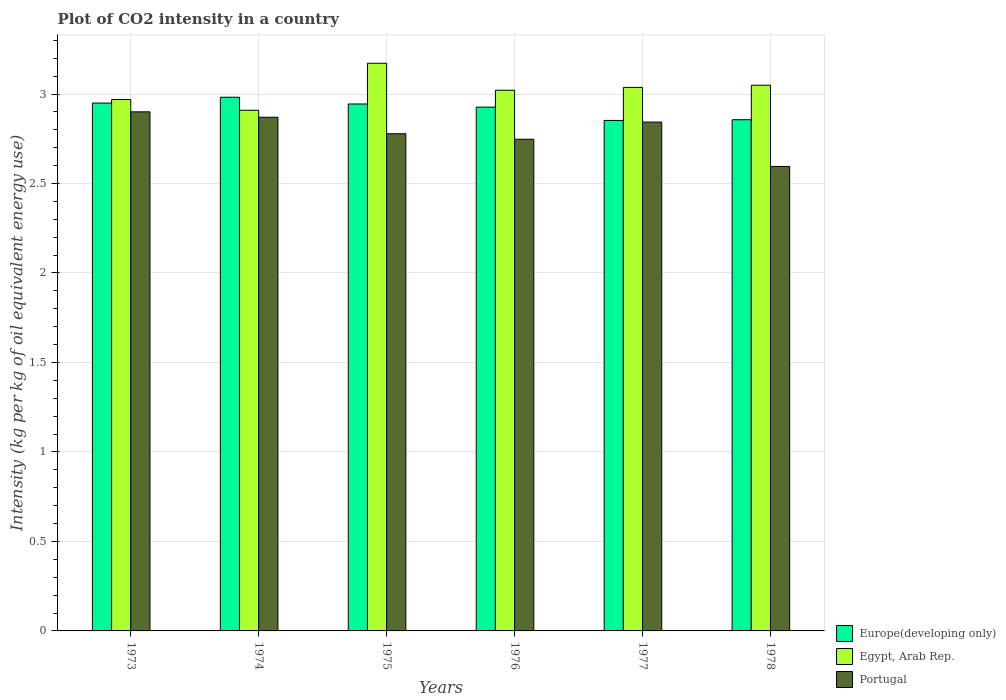How many different coloured bars are there?
Offer a terse response. 3. How many groups of bars are there?
Make the answer very short. 6. Are the number of bars per tick equal to the number of legend labels?
Your answer should be compact. Yes. Are the number of bars on each tick of the X-axis equal?
Offer a very short reply. Yes. How many bars are there on the 5th tick from the left?
Offer a very short reply. 3. What is the label of the 5th group of bars from the left?
Your response must be concise. 1977. What is the CO2 intensity in in Portugal in 1976?
Provide a succinct answer. 2.75. Across all years, what is the maximum CO2 intensity in in Europe(developing only)?
Your answer should be compact. 2.98. Across all years, what is the minimum CO2 intensity in in Egypt, Arab Rep.?
Provide a succinct answer. 2.91. In which year was the CO2 intensity in in Egypt, Arab Rep. maximum?
Your answer should be compact. 1975. What is the total CO2 intensity in in Egypt, Arab Rep. in the graph?
Your response must be concise. 18.16. What is the difference between the CO2 intensity in in Egypt, Arab Rep. in 1975 and that in 1976?
Make the answer very short. 0.15. What is the difference between the CO2 intensity in in Egypt, Arab Rep. in 1975 and the CO2 intensity in in Europe(developing only) in 1976?
Ensure brevity in your answer.  0.25. What is the average CO2 intensity in in Egypt, Arab Rep. per year?
Your answer should be very brief. 3.03. In the year 1975, what is the difference between the CO2 intensity in in Portugal and CO2 intensity in in Europe(developing only)?
Give a very brief answer. -0.17. In how many years, is the CO2 intensity in in Egypt, Arab Rep. greater than 1.1 kg?
Offer a terse response. 6. What is the ratio of the CO2 intensity in in Portugal in 1975 to that in 1977?
Your answer should be compact. 0.98. Is the CO2 intensity in in Europe(developing only) in 1973 less than that in 1976?
Ensure brevity in your answer.  No. Is the difference between the CO2 intensity in in Portugal in 1974 and 1977 greater than the difference between the CO2 intensity in in Europe(developing only) in 1974 and 1977?
Your answer should be very brief. No. What is the difference between the highest and the second highest CO2 intensity in in Egypt, Arab Rep.?
Your response must be concise. 0.12. What is the difference between the highest and the lowest CO2 intensity in in Egypt, Arab Rep.?
Keep it short and to the point. 0.26. What does the 2nd bar from the left in 1974 represents?
Provide a short and direct response. Egypt, Arab Rep. What does the 1st bar from the right in 1974 represents?
Your answer should be very brief. Portugal. How many bars are there?
Your answer should be compact. 18. Does the graph contain any zero values?
Provide a succinct answer. No. Does the graph contain grids?
Offer a terse response. Yes. What is the title of the graph?
Make the answer very short. Plot of CO2 intensity in a country. What is the label or title of the X-axis?
Make the answer very short. Years. What is the label or title of the Y-axis?
Provide a short and direct response. Intensity (kg per kg of oil equivalent energy use). What is the Intensity (kg per kg of oil equivalent energy use) of Europe(developing only) in 1973?
Your answer should be very brief. 2.95. What is the Intensity (kg per kg of oil equivalent energy use) in Egypt, Arab Rep. in 1973?
Provide a short and direct response. 2.97. What is the Intensity (kg per kg of oil equivalent energy use) in Portugal in 1973?
Make the answer very short. 2.9. What is the Intensity (kg per kg of oil equivalent energy use) in Europe(developing only) in 1974?
Give a very brief answer. 2.98. What is the Intensity (kg per kg of oil equivalent energy use) in Egypt, Arab Rep. in 1974?
Your response must be concise. 2.91. What is the Intensity (kg per kg of oil equivalent energy use) in Portugal in 1974?
Your response must be concise. 2.87. What is the Intensity (kg per kg of oil equivalent energy use) of Europe(developing only) in 1975?
Offer a terse response. 2.94. What is the Intensity (kg per kg of oil equivalent energy use) in Egypt, Arab Rep. in 1975?
Your response must be concise. 3.17. What is the Intensity (kg per kg of oil equivalent energy use) of Portugal in 1975?
Your answer should be compact. 2.78. What is the Intensity (kg per kg of oil equivalent energy use) of Europe(developing only) in 1976?
Keep it short and to the point. 2.93. What is the Intensity (kg per kg of oil equivalent energy use) of Egypt, Arab Rep. in 1976?
Make the answer very short. 3.02. What is the Intensity (kg per kg of oil equivalent energy use) of Portugal in 1976?
Provide a short and direct response. 2.75. What is the Intensity (kg per kg of oil equivalent energy use) in Europe(developing only) in 1977?
Offer a terse response. 2.85. What is the Intensity (kg per kg of oil equivalent energy use) in Egypt, Arab Rep. in 1977?
Provide a short and direct response. 3.04. What is the Intensity (kg per kg of oil equivalent energy use) of Portugal in 1977?
Ensure brevity in your answer.  2.84. What is the Intensity (kg per kg of oil equivalent energy use) of Europe(developing only) in 1978?
Offer a terse response. 2.86. What is the Intensity (kg per kg of oil equivalent energy use) of Egypt, Arab Rep. in 1978?
Offer a terse response. 3.05. What is the Intensity (kg per kg of oil equivalent energy use) of Portugal in 1978?
Provide a succinct answer. 2.6. Across all years, what is the maximum Intensity (kg per kg of oil equivalent energy use) of Europe(developing only)?
Ensure brevity in your answer.  2.98. Across all years, what is the maximum Intensity (kg per kg of oil equivalent energy use) in Egypt, Arab Rep.?
Your response must be concise. 3.17. Across all years, what is the maximum Intensity (kg per kg of oil equivalent energy use) in Portugal?
Give a very brief answer. 2.9. Across all years, what is the minimum Intensity (kg per kg of oil equivalent energy use) of Europe(developing only)?
Make the answer very short. 2.85. Across all years, what is the minimum Intensity (kg per kg of oil equivalent energy use) in Egypt, Arab Rep.?
Keep it short and to the point. 2.91. Across all years, what is the minimum Intensity (kg per kg of oil equivalent energy use) of Portugal?
Keep it short and to the point. 2.6. What is the total Intensity (kg per kg of oil equivalent energy use) in Europe(developing only) in the graph?
Keep it short and to the point. 17.51. What is the total Intensity (kg per kg of oil equivalent energy use) of Egypt, Arab Rep. in the graph?
Your answer should be very brief. 18.16. What is the total Intensity (kg per kg of oil equivalent energy use) of Portugal in the graph?
Give a very brief answer. 16.74. What is the difference between the Intensity (kg per kg of oil equivalent energy use) in Europe(developing only) in 1973 and that in 1974?
Make the answer very short. -0.03. What is the difference between the Intensity (kg per kg of oil equivalent energy use) in Portugal in 1973 and that in 1974?
Provide a succinct answer. 0.03. What is the difference between the Intensity (kg per kg of oil equivalent energy use) in Europe(developing only) in 1973 and that in 1975?
Ensure brevity in your answer.  0.01. What is the difference between the Intensity (kg per kg of oil equivalent energy use) in Egypt, Arab Rep. in 1973 and that in 1975?
Provide a succinct answer. -0.2. What is the difference between the Intensity (kg per kg of oil equivalent energy use) in Portugal in 1973 and that in 1975?
Make the answer very short. 0.12. What is the difference between the Intensity (kg per kg of oil equivalent energy use) of Europe(developing only) in 1973 and that in 1976?
Ensure brevity in your answer.  0.02. What is the difference between the Intensity (kg per kg of oil equivalent energy use) of Egypt, Arab Rep. in 1973 and that in 1976?
Your answer should be compact. -0.05. What is the difference between the Intensity (kg per kg of oil equivalent energy use) of Portugal in 1973 and that in 1976?
Offer a terse response. 0.15. What is the difference between the Intensity (kg per kg of oil equivalent energy use) of Europe(developing only) in 1973 and that in 1977?
Provide a succinct answer. 0.1. What is the difference between the Intensity (kg per kg of oil equivalent energy use) in Egypt, Arab Rep. in 1973 and that in 1977?
Keep it short and to the point. -0.07. What is the difference between the Intensity (kg per kg of oil equivalent energy use) in Portugal in 1973 and that in 1977?
Your answer should be compact. 0.06. What is the difference between the Intensity (kg per kg of oil equivalent energy use) of Europe(developing only) in 1973 and that in 1978?
Keep it short and to the point. 0.09. What is the difference between the Intensity (kg per kg of oil equivalent energy use) of Egypt, Arab Rep. in 1973 and that in 1978?
Your answer should be very brief. -0.08. What is the difference between the Intensity (kg per kg of oil equivalent energy use) in Portugal in 1973 and that in 1978?
Provide a short and direct response. 0.31. What is the difference between the Intensity (kg per kg of oil equivalent energy use) of Europe(developing only) in 1974 and that in 1975?
Offer a terse response. 0.04. What is the difference between the Intensity (kg per kg of oil equivalent energy use) of Egypt, Arab Rep. in 1974 and that in 1975?
Make the answer very short. -0.26. What is the difference between the Intensity (kg per kg of oil equivalent energy use) of Portugal in 1974 and that in 1975?
Provide a succinct answer. 0.09. What is the difference between the Intensity (kg per kg of oil equivalent energy use) in Europe(developing only) in 1974 and that in 1976?
Offer a very short reply. 0.06. What is the difference between the Intensity (kg per kg of oil equivalent energy use) in Egypt, Arab Rep. in 1974 and that in 1976?
Your answer should be very brief. -0.11. What is the difference between the Intensity (kg per kg of oil equivalent energy use) of Portugal in 1974 and that in 1976?
Provide a succinct answer. 0.12. What is the difference between the Intensity (kg per kg of oil equivalent energy use) of Europe(developing only) in 1974 and that in 1977?
Offer a very short reply. 0.13. What is the difference between the Intensity (kg per kg of oil equivalent energy use) in Egypt, Arab Rep. in 1974 and that in 1977?
Offer a terse response. -0.13. What is the difference between the Intensity (kg per kg of oil equivalent energy use) of Portugal in 1974 and that in 1977?
Keep it short and to the point. 0.03. What is the difference between the Intensity (kg per kg of oil equivalent energy use) in Europe(developing only) in 1974 and that in 1978?
Give a very brief answer. 0.13. What is the difference between the Intensity (kg per kg of oil equivalent energy use) of Egypt, Arab Rep. in 1974 and that in 1978?
Ensure brevity in your answer.  -0.14. What is the difference between the Intensity (kg per kg of oil equivalent energy use) of Portugal in 1974 and that in 1978?
Offer a very short reply. 0.28. What is the difference between the Intensity (kg per kg of oil equivalent energy use) in Europe(developing only) in 1975 and that in 1976?
Ensure brevity in your answer.  0.02. What is the difference between the Intensity (kg per kg of oil equivalent energy use) in Egypt, Arab Rep. in 1975 and that in 1976?
Offer a terse response. 0.15. What is the difference between the Intensity (kg per kg of oil equivalent energy use) of Portugal in 1975 and that in 1976?
Keep it short and to the point. 0.03. What is the difference between the Intensity (kg per kg of oil equivalent energy use) in Europe(developing only) in 1975 and that in 1977?
Your response must be concise. 0.09. What is the difference between the Intensity (kg per kg of oil equivalent energy use) of Egypt, Arab Rep. in 1975 and that in 1977?
Your response must be concise. 0.13. What is the difference between the Intensity (kg per kg of oil equivalent energy use) in Portugal in 1975 and that in 1977?
Ensure brevity in your answer.  -0.07. What is the difference between the Intensity (kg per kg of oil equivalent energy use) in Europe(developing only) in 1975 and that in 1978?
Your response must be concise. 0.09. What is the difference between the Intensity (kg per kg of oil equivalent energy use) in Egypt, Arab Rep. in 1975 and that in 1978?
Keep it short and to the point. 0.12. What is the difference between the Intensity (kg per kg of oil equivalent energy use) of Portugal in 1975 and that in 1978?
Give a very brief answer. 0.18. What is the difference between the Intensity (kg per kg of oil equivalent energy use) of Europe(developing only) in 1976 and that in 1977?
Provide a short and direct response. 0.07. What is the difference between the Intensity (kg per kg of oil equivalent energy use) in Egypt, Arab Rep. in 1976 and that in 1977?
Your answer should be compact. -0.02. What is the difference between the Intensity (kg per kg of oil equivalent energy use) of Portugal in 1976 and that in 1977?
Make the answer very short. -0.1. What is the difference between the Intensity (kg per kg of oil equivalent energy use) of Europe(developing only) in 1976 and that in 1978?
Keep it short and to the point. 0.07. What is the difference between the Intensity (kg per kg of oil equivalent energy use) in Egypt, Arab Rep. in 1976 and that in 1978?
Your response must be concise. -0.03. What is the difference between the Intensity (kg per kg of oil equivalent energy use) in Portugal in 1976 and that in 1978?
Make the answer very short. 0.15. What is the difference between the Intensity (kg per kg of oil equivalent energy use) in Europe(developing only) in 1977 and that in 1978?
Provide a short and direct response. -0. What is the difference between the Intensity (kg per kg of oil equivalent energy use) in Egypt, Arab Rep. in 1977 and that in 1978?
Ensure brevity in your answer.  -0.01. What is the difference between the Intensity (kg per kg of oil equivalent energy use) of Portugal in 1977 and that in 1978?
Ensure brevity in your answer.  0.25. What is the difference between the Intensity (kg per kg of oil equivalent energy use) of Europe(developing only) in 1973 and the Intensity (kg per kg of oil equivalent energy use) of Egypt, Arab Rep. in 1974?
Your answer should be compact. 0.04. What is the difference between the Intensity (kg per kg of oil equivalent energy use) in Europe(developing only) in 1973 and the Intensity (kg per kg of oil equivalent energy use) in Portugal in 1974?
Your response must be concise. 0.08. What is the difference between the Intensity (kg per kg of oil equivalent energy use) of Egypt, Arab Rep. in 1973 and the Intensity (kg per kg of oil equivalent energy use) of Portugal in 1974?
Your answer should be compact. 0.1. What is the difference between the Intensity (kg per kg of oil equivalent energy use) of Europe(developing only) in 1973 and the Intensity (kg per kg of oil equivalent energy use) of Egypt, Arab Rep. in 1975?
Your answer should be compact. -0.22. What is the difference between the Intensity (kg per kg of oil equivalent energy use) in Europe(developing only) in 1973 and the Intensity (kg per kg of oil equivalent energy use) in Portugal in 1975?
Provide a short and direct response. 0.17. What is the difference between the Intensity (kg per kg of oil equivalent energy use) of Egypt, Arab Rep. in 1973 and the Intensity (kg per kg of oil equivalent energy use) of Portugal in 1975?
Your response must be concise. 0.19. What is the difference between the Intensity (kg per kg of oil equivalent energy use) in Europe(developing only) in 1973 and the Intensity (kg per kg of oil equivalent energy use) in Egypt, Arab Rep. in 1976?
Give a very brief answer. -0.07. What is the difference between the Intensity (kg per kg of oil equivalent energy use) in Europe(developing only) in 1973 and the Intensity (kg per kg of oil equivalent energy use) in Portugal in 1976?
Your response must be concise. 0.2. What is the difference between the Intensity (kg per kg of oil equivalent energy use) of Egypt, Arab Rep. in 1973 and the Intensity (kg per kg of oil equivalent energy use) of Portugal in 1976?
Provide a short and direct response. 0.22. What is the difference between the Intensity (kg per kg of oil equivalent energy use) of Europe(developing only) in 1973 and the Intensity (kg per kg of oil equivalent energy use) of Egypt, Arab Rep. in 1977?
Give a very brief answer. -0.09. What is the difference between the Intensity (kg per kg of oil equivalent energy use) of Europe(developing only) in 1973 and the Intensity (kg per kg of oil equivalent energy use) of Portugal in 1977?
Your answer should be very brief. 0.11. What is the difference between the Intensity (kg per kg of oil equivalent energy use) in Egypt, Arab Rep. in 1973 and the Intensity (kg per kg of oil equivalent energy use) in Portugal in 1977?
Your response must be concise. 0.13. What is the difference between the Intensity (kg per kg of oil equivalent energy use) of Europe(developing only) in 1973 and the Intensity (kg per kg of oil equivalent energy use) of Egypt, Arab Rep. in 1978?
Make the answer very short. -0.1. What is the difference between the Intensity (kg per kg of oil equivalent energy use) in Europe(developing only) in 1973 and the Intensity (kg per kg of oil equivalent energy use) in Portugal in 1978?
Your response must be concise. 0.35. What is the difference between the Intensity (kg per kg of oil equivalent energy use) of Egypt, Arab Rep. in 1973 and the Intensity (kg per kg of oil equivalent energy use) of Portugal in 1978?
Your answer should be compact. 0.37. What is the difference between the Intensity (kg per kg of oil equivalent energy use) in Europe(developing only) in 1974 and the Intensity (kg per kg of oil equivalent energy use) in Egypt, Arab Rep. in 1975?
Offer a terse response. -0.19. What is the difference between the Intensity (kg per kg of oil equivalent energy use) of Europe(developing only) in 1974 and the Intensity (kg per kg of oil equivalent energy use) of Portugal in 1975?
Give a very brief answer. 0.2. What is the difference between the Intensity (kg per kg of oil equivalent energy use) in Egypt, Arab Rep. in 1974 and the Intensity (kg per kg of oil equivalent energy use) in Portugal in 1975?
Provide a short and direct response. 0.13. What is the difference between the Intensity (kg per kg of oil equivalent energy use) in Europe(developing only) in 1974 and the Intensity (kg per kg of oil equivalent energy use) in Egypt, Arab Rep. in 1976?
Your answer should be compact. -0.04. What is the difference between the Intensity (kg per kg of oil equivalent energy use) of Europe(developing only) in 1974 and the Intensity (kg per kg of oil equivalent energy use) of Portugal in 1976?
Your answer should be compact. 0.23. What is the difference between the Intensity (kg per kg of oil equivalent energy use) of Egypt, Arab Rep. in 1974 and the Intensity (kg per kg of oil equivalent energy use) of Portugal in 1976?
Your response must be concise. 0.16. What is the difference between the Intensity (kg per kg of oil equivalent energy use) in Europe(developing only) in 1974 and the Intensity (kg per kg of oil equivalent energy use) in Egypt, Arab Rep. in 1977?
Your answer should be compact. -0.06. What is the difference between the Intensity (kg per kg of oil equivalent energy use) in Europe(developing only) in 1974 and the Intensity (kg per kg of oil equivalent energy use) in Portugal in 1977?
Your answer should be very brief. 0.14. What is the difference between the Intensity (kg per kg of oil equivalent energy use) in Egypt, Arab Rep. in 1974 and the Intensity (kg per kg of oil equivalent energy use) in Portugal in 1977?
Your response must be concise. 0.07. What is the difference between the Intensity (kg per kg of oil equivalent energy use) in Europe(developing only) in 1974 and the Intensity (kg per kg of oil equivalent energy use) in Egypt, Arab Rep. in 1978?
Your response must be concise. -0.07. What is the difference between the Intensity (kg per kg of oil equivalent energy use) in Europe(developing only) in 1974 and the Intensity (kg per kg of oil equivalent energy use) in Portugal in 1978?
Your response must be concise. 0.39. What is the difference between the Intensity (kg per kg of oil equivalent energy use) of Egypt, Arab Rep. in 1974 and the Intensity (kg per kg of oil equivalent energy use) of Portugal in 1978?
Keep it short and to the point. 0.31. What is the difference between the Intensity (kg per kg of oil equivalent energy use) of Europe(developing only) in 1975 and the Intensity (kg per kg of oil equivalent energy use) of Egypt, Arab Rep. in 1976?
Offer a terse response. -0.08. What is the difference between the Intensity (kg per kg of oil equivalent energy use) of Europe(developing only) in 1975 and the Intensity (kg per kg of oil equivalent energy use) of Portugal in 1976?
Provide a succinct answer. 0.2. What is the difference between the Intensity (kg per kg of oil equivalent energy use) of Egypt, Arab Rep. in 1975 and the Intensity (kg per kg of oil equivalent energy use) of Portugal in 1976?
Keep it short and to the point. 0.42. What is the difference between the Intensity (kg per kg of oil equivalent energy use) of Europe(developing only) in 1975 and the Intensity (kg per kg of oil equivalent energy use) of Egypt, Arab Rep. in 1977?
Offer a terse response. -0.09. What is the difference between the Intensity (kg per kg of oil equivalent energy use) in Europe(developing only) in 1975 and the Intensity (kg per kg of oil equivalent energy use) in Portugal in 1977?
Provide a short and direct response. 0.1. What is the difference between the Intensity (kg per kg of oil equivalent energy use) of Egypt, Arab Rep. in 1975 and the Intensity (kg per kg of oil equivalent energy use) of Portugal in 1977?
Give a very brief answer. 0.33. What is the difference between the Intensity (kg per kg of oil equivalent energy use) of Europe(developing only) in 1975 and the Intensity (kg per kg of oil equivalent energy use) of Egypt, Arab Rep. in 1978?
Give a very brief answer. -0.1. What is the difference between the Intensity (kg per kg of oil equivalent energy use) of Europe(developing only) in 1975 and the Intensity (kg per kg of oil equivalent energy use) of Portugal in 1978?
Provide a succinct answer. 0.35. What is the difference between the Intensity (kg per kg of oil equivalent energy use) of Egypt, Arab Rep. in 1975 and the Intensity (kg per kg of oil equivalent energy use) of Portugal in 1978?
Make the answer very short. 0.58. What is the difference between the Intensity (kg per kg of oil equivalent energy use) of Europe(developing only) in 1976 and the Intensity (kg per kg of oil equivalent energy use) of Egypt, Arab Rep. in 1977?
Provide a succinct answer. -0.11. What is the difference between the Intensity (kg per kg of oil equivalent energy use) in Europe(developing only) in 1976 and the Intensity (kg per kg of oil equivalent energy use) in Portugal in 1977?
Keep it short and to the point. 0.08. What is the difference between the Intensity (kg per kg of oil equivalent energy use) of Egypt, Arab Rep. in 1976 and the Intensity (kg per kg of oil equivalent energy use) of Portugal in 1977?
Ensure brevity in your answer.  0.18. What is the difference between the Intensity (kg per kg of oil equivalent energy use) of Europe(developing only) in 1976 and the Intensity (kg per kg of oil equivalent energy use) of Egypt, Arab Rep. in 1978?
Make the answer very short. -0.12. What is the difference between the Intensity (kg per kg of oil equivalent energy use) of Europe(developing only) in 1976 and the Intensity (kg per kg of oil equivalent energy use) of Portugal in 1978?
Provide a succinct answer. 0.33. What is the difference between the Intensity (kg per kg of oil equivalent energy use) in Egypt, Arab Rep. in 1976 and the Intensity (kg per kg of oil equivalent energy use) in Portugal in 1978?
Give a very brief answer. 0.43. What is the difference between the Intensity (kg per kg of oil equivalent energy use) of Europe(developing only) in 1977 and the Intensity (kg per kg of oil equivalent energy use) of Egypt, Arab Rep. in 1978?
Keep it short and to the point. -0.2. What is the difference between the Intensity (kg per kg of oil equivalent energy use) of Europe(developing only) in 1977 and the Intensity (kg per kg of oil equivalent energy use) of Portugal in 1978?
Ensure brevity in your answer.  0.26. What is the difference between the Intensity (kg per kg of oil equivalent energy use) in Egypt, Arab Rep. in 1977 and the Intensity (kg per kg of oil equivalent energy use) in Portugal in 1978?
Offer a terse response. 0.44. What is the average Intensity (kg per kg of oil equivalent energy use) in Europe(developing only) per year?
Offer a terse response. 2.92. What is the average Intensity (kg per kg of oil equivalent energy use) in Egypt, Arab Rep. per year?
Your response must be concise. 3.03. What is the average Intensity (kg per kg of oil equivalent energy use) of Portugal per year?
Your answer should be compact. 2.79. In the year 1973, what is the difference between the Intensity (kg per kg of oil equivalent energy use) in Europe(developing only) and Intensity (kg per kg of oil equivalent energy use) in Egypt, Arab Rep.?
Keep it short and to the point. -0.02. In the year 1973, what is the difference between the Intensity (kg per kg of oil equivalent energy use) of Europe(developing only) and Intensity (kg per kg of oil equivalent energy use) of Portugal?
Make the answer very short. 0.05. In the year 1973, what is the difference between the Intensity (kg per kg of oil equivalent energy use) of Egypt, Arab Rep. and Intensity (kg per kg of oil equivalent energy use) of Portugal?
Make the answer very short. 0.07. In the year 1974, what is the difference between the Intensity (kg per kg of oil equivalent energy use) of Europe(developing only) and Intensity (kg per kg of oil equivalent energy use) of Egypt, Arab Rep.?
Provide a succinct answer. 0.07. In the year 1974, what is the difference between the Intensity (kg per kg of oil equivalent energy use) of Europe(developing only) and Intensity (kg per kg of oil equivalent energy use) of Portugal?
Make the answer very short. 0.11. In the year 1974, what is the difference between the Intensity (kg per kg of oil equivalent energy use) of Egypt, Arab Rep. and Intensity (kg per kg of oil equivalent energy use) of Portugal?
Your answer should be compact. 0.04. In the year 1975, what is the difference between the Intensity (kg per kg of oil equivalent energy use) of Europe(developing only) and Intensity (kg per kg of oil equivalent energy use) of Egypt, Arab Rep.?
Ensure brevity in your answer.  -0.23. In the year 1975, what is the difference between the Intensity (kg per kg of oil equivalent energy use) in Europe(developing only) and Intensity (kg per kg of oil equivalent energy use) in Portugal?
Offer a terse response. 0.17. In the year 1975, what is the difference between the Intensity (kg per kg of oil equivalent energy use) in Egypt, Arab Rep. and Intensity (kg per kg of oil equivalent energy use) in Portugal?
Your answer should be very brief. 0.39. In the year 1976, what is the difference between the Intensity (kg per kg of oil equivalent energy use) in Europe(developing only) and Intensity (kg per kg of oil equivalent energy use) in Egypt, Arab Rep.?
Give a very brief answer. -0.09. In the year 1976, what is the difference between the Intensity (kg per kg of oil equivalent energy use) of Europe(developing only) and Intensity (kg per kg of oil equivalent energy use) of Portugal?
Provide a short and direct response. 0.18. In the year 1976, what is the difference between the Intensity (kg per kg of oil equivalent energy use) in Egypt, Arab Rep. and Intensity (kg per kg of oil equivalent energy use) in Portugal?
Keep it short and to the point. 0.27. In the year 1977, what is the difference between the Intensity (kg per kg of oil equivalent energy use) of Europe(developing only) and Intensity (kg per kg of oil equivalent energy use) of Egypt, Arab Rep.?
Offer a terse response. -0.18. In the year 1977, what is the difference between the Intensity (kg per kg of oil equivalent energy use) in Europe(developing only) and Intensity (kg per kg of oil equivalent energy use) in Portugal?
Your answer should be compact. 0.01. In the year 1977, what is the difference between the Intensity (kg per kg of oil equivalent energy use) of Egypt, Arab Rep. and Intensity (kg per kg of oil equivalent energy use) of Portugal?
Offer a terse response. 0.19. In the year 1978, what is the difference between the Intensity (kg per kg of oil equivalent energy use) in Europe(developing only) and Intensity (kg per kg of oil equivalent energy use) in Egypt, Arab Rep.?
Your answer should be very brief. -0.19. In the year 1978, what is the difference between the Intensity (kg per kg of oil equivalent energy use) of Europe(developing only) and Intensity (kg per kg of oil equivalent energy use) of Portugal?
Your response must be concise. 0.26. In the year 1978, what is the difference between the Intensity (kg per kg of oil equivalent energy use) in Egypt, Arab Rep. and Intensity (kg per kg of oil equivalent energy use) in Portugal?
Make the answer very short. 0.45. What is the ratio of the Intensity (kg per kg of oil equivalent energy use) of Egypt, Arab Rep. in 1973 to that in 1974?
Your answer should be compact. 1.02. What is the ratio of the Intensity (kg per kg of oil equivalent energy use) in Portugal in 1973 to that in 1974?
Ensure brevity in your answer.  1.01. What is the ratio of the Intensity (kg per kg of oil equivalent energy use) of Europe(developing only) in 1973 to that in 1975?
Offer a terse response. 1. What is the ratio of the Intensity (kg per kg of oil equivalent energy use) of Egypt, Arab Rep. in 1973 to that in 1975?
Your response must be concise. 0.94. What is the ratio of the Intensity (kg per kg of oil equivalent energy use) in Portugal in 1973 to that in 1975?
Provide a short and direct response. 1.04. What is the ratio of the Intensity (kg per kg of oil equivalent energy use) of Europe(developing only) in 1973 to that in 1976?
Keep it short and to the point. 1.01. What is the ratio of the Intensity (kg per kg of oil equivalent energy use) of Egypt, Arab Rep. in 1973 to that in 1976?
Make the answer very short. 0.98. What is the ratio of the Intensity (kg per kg of oil equivalent energy use) in Portugal in 1973 to that in 1976?
Your answer should be very brief. 1.06. What is the ratio of the Intensity (kg per kg of oil equivalent energy use) in Europe(developing only) in 1973 to that in 1977?
Your response must be concise. 1.03. What is the ratio of the Intensity (kg per kg of oil equivalent energy use) in Egypt, Arab Rep. in 1973 to that in 1977?
Give a very brief answer. 0.98. What is the ratio of the Intensity (kg per kg of oil equivalent energy use) of Portugal in 1973 to that in 1977?
Your answer should be compact. 1.02. What is the ratio of the Intensity (kg per kg of oil equivalent energy use) in Europe(developing only) in 1973 to that in 1978?
Give a very brief answer. 1.03. What is the ratio of the Intensity (kg per kg of oil equivalent energy use) in Egypt, Arab Rep. in 1973 to that in 1978?
Your response must be concise. 0.97. What is the ratio of the Intensity (kg per kg of oil equivalent energy use) in Portugal in 1973 to that in 1978?
Provide a succinct answer. 1.12. What is the ratio of the Intensity (kg per kg of oil equivalent energy use) in Europe(developing only) in 1974 to that in 1975?
Offer a terse response. 1.01. What is the ratio of the Intensity (kg per kg of oil equivalent energy use) in Egypt, Arab Rep. in 1974 to that in 1975?
Your answer should be compact. 0.92. What is the ratio of the Intensity (kg per kg of oil equivalent energy use) in Portugal in 1974 to that in 1975?
Offer a terse response. 1.03. What is the ratio of the Intensity (kg per kg of oil equivalent energy use) in Europe(developing only) in 1974 to that in 1976?
Provide a short and direct response. 1.02. What is the ratio of the Intensity (kg per kg of oil equivalent energy use) in Egypt, Arab Rep. in 1974 to that in 1976?
Provide a short and direct response. 0.96. What is the ratio of the Intensity (kg per kg of oil equivalent energy use) of Portugal in 1974 to that in 1976?
Your answer should be compact. 1.04. What is the ratio of the Intensity (kg per kg of oil equivalent energy use) in Europe(developing only) in 1974 to that in 1977?
Your answer should be very brief. 1.05. What is the ratio of the Intensity (kg per kg of oil equivalent energy use) of Egypt, Arab Rep. in 1974 to that in 1977?
Offer a terse response. 0.96. What is the ratio of the Intensity (kg per kg of oil equivalent energy use) of Portugal in 1974 to that in 1977?
Your response must be concise. 1.01. What is the ratio of the Intensity (kg per kg of oil equivalent energy use) in Europe(developing only) in 1974 to that in 1978?
Your answer should be very brief. 1.04. What is the ratio of the Intensity (kg per kg of oil equivalent energy use) of Egypt, Arab Rep. in 1974 to that in 1978?
Offer a terse response. 0.95. What is the ratio of the Intensity (kg per kg of oil equivalent energy use) of Portugal in 1974 to that in 1978?
Ensure brevity in your answer.  1.11. What is the ratio of the Intensity (kg per kg of oil equivalent energy use) of Europe(developing only) in 1975 to that in 1976?
Offer a very short reply. 1.01. What is the ratio of the Intensity (kg per kg of oil equivalent energy use) in Egypt, Arab Rep. in 1975 to that in 1976?
Your response must be concise. 1.05. What is the ratio of the Intensity (kg per kg of oil equivalent energy use) in Portugal in 1975 to that in 1976?
Your response must be concise. 1.01. What is the ratio of the Intensity (kg per kg of oil equivalent energy use) in Europe(developing only) in 1975 to that in 1977?
Give a very brief answer. 1.03. What is the ratio of the Intensity (kg per kg of oil equivalent energy use) of Egypt, Arab Rep. in 1975 to that in 1977?
Your answer should be compact. 1.04. What is the ratio of the Intensity (kg per kg of oil equivalent energy use) of Portugal in 1975 to that in 1977?
Provide a succinct answer. 0.98. What is the ratio of the Intensity (kg per kg of oil equivalent energy use) of Europe(developing only) in 1975 to that in 1978?
Your answer should be compact. 1.03. What is the ratio of the Intensity (kg per kg of oil equivalent energy use) of Egypt, Arab Rep. in 1975 to that in 1978?
Ensure brevity in your answer.  1.04. What is the ratio of the Intensity (kg per kg of oil equivalent energy use) in Portugal in 1975 to that in 1978?
Your answer should be very brief. 1.07. What is the ratio of the Intensity (kg per kg of oil equivalent energy use) of Europe(developing only) in 1976 to that in 1977?
Offer a terse response. 1.03. What is the ratio of the Intensity (kg per kg of oil equivalent energy use) in Portugal in 1976 to that in 1977?
Offer a very short reply. 0.97. What is the ratio of the Intensity (kg per kg of oil equivalent energy use) of Europe(developing only) in 1976 to that in 1978?
Your answer should be compact. 1.02. What is the ratio of the Intensity (kg per kg of oil equivalent energy use) in Egypt, Arab Rep. in 1976 to that in 1978?
Keep it short and to the point. 0.99. What is the ratio of the Intensity (kg per kg of oil equivalent energy use) of Portugal in 1976 to that in 1978?
Offer a very short reply. 1.06. What is the ratio of the Intensity (kg per kg of oil equivalent energy use) of Egypt, Arab Rep. in 1977 to that in 1978?
Ensure brevity in your answer.  1. What is the ratio of the Intensity (kg per kg of oil equivalent energy use) in Portugal in 1977 to that in 1978?
Your answer should be compact. 1.1. What is the difference between the highest and the second highest Intensity (kg per kg of oil equivalent energy use) in Europe(developing only)?
Make the answer very short. 0.03. What is the difference between the highest and the second highest Intensity (kg per kg of oil equivalent energy use) in Egypt, Arab Rep.?
Ensure brevity in your answer.  0.12. What is the difference between the highest and the second highest Intensity (kg per kg of oil equivalent energy use) in Portugal?
Make the answer very short. 0.03. What is the difference between the highest and the lowest Intensity (kg per kg of oil equivalent energy use) of Europe(developing only)?
Your response must be concise. 0.13. What is the difference between the highest and the lowest Intensity (kg per kg of oil equivalent energy use) of Egypt, Arab Rep.?
Give a very brief answer. 0.26. What is the difference between the highest and the lowest Intensity (kg per kg of oil equivalent energy use) of Portugal?
Offer a terse response. 0.31. 